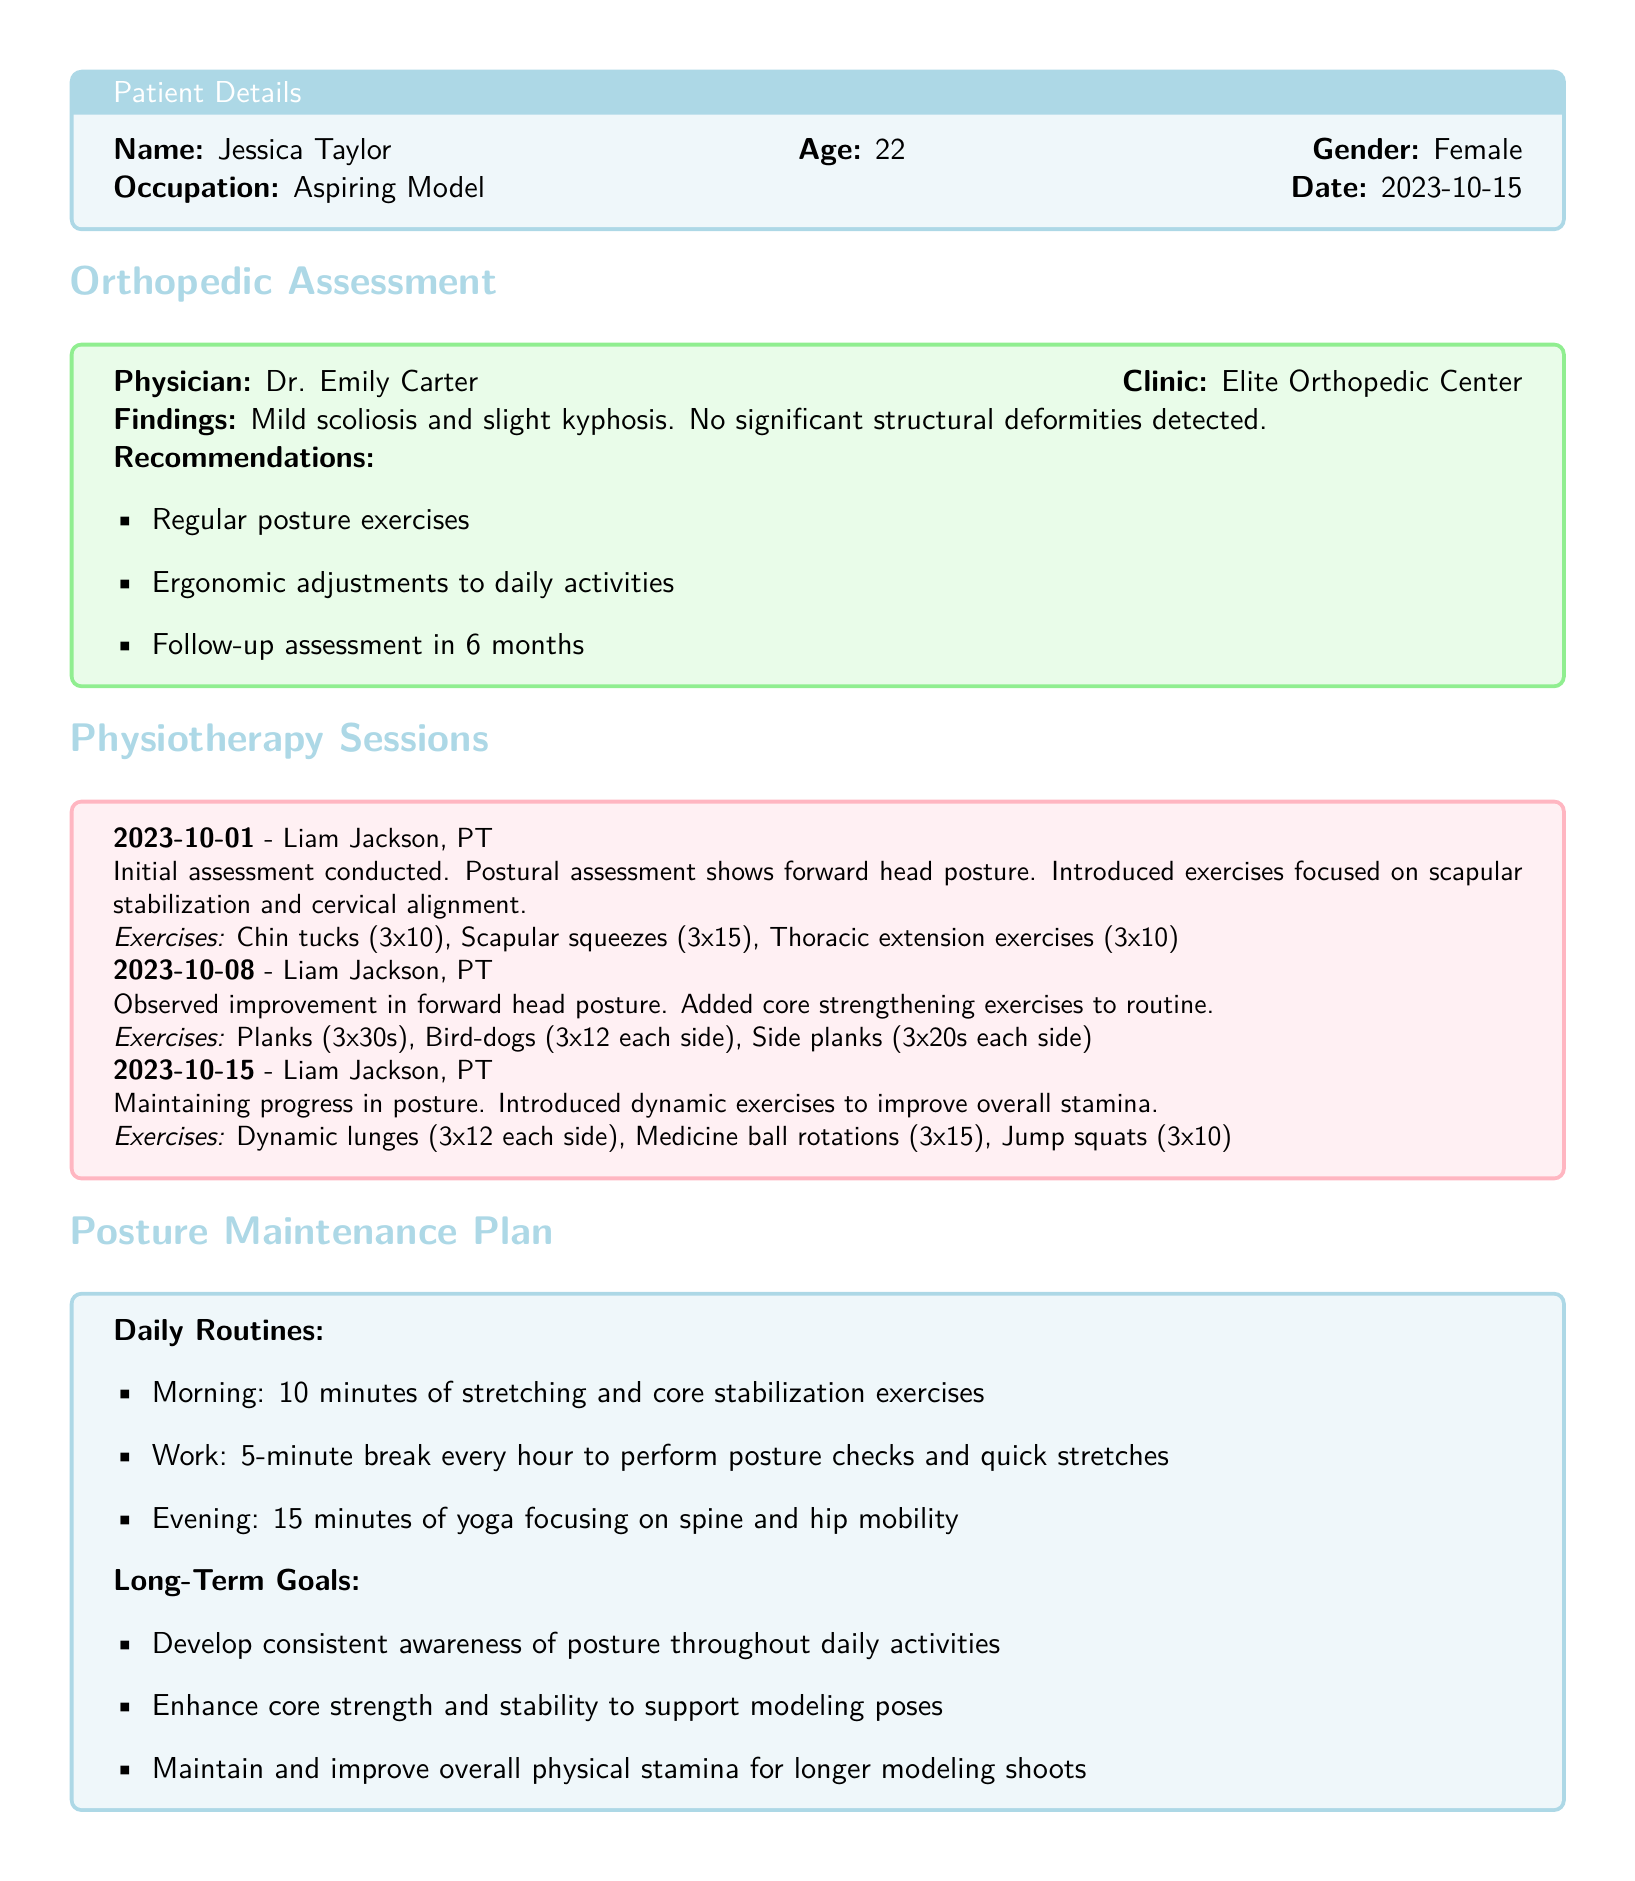What is the name of the patient? The name of the patient is provided in the patient details section.
Answer: Jessica Taylor What is the date of the orthopedic assessment? The date of the orthopedic assessment can be found near the top of the document.
Answer: 2023-10-15 Who conducted the initial physiotherapy assessment? The name of the physiotherapist who conducted the initial assessment is noted in the physiotherapy sessions section.
Answer: Liam Jackson What exercise was introduced on 2023-10-15? The exercise introduced during the session on this date is listed in the physiotherapy sessions section.
Answer: Dynamic lunges What long-term goal is related to core strength? The long-term goal concerning core strength is noted in the posture maintenance plan section.
Answer: Enhance core strength and stability to support modeling poses How many repetitions of thoracic extension exercises are prescribed? The number of repetitions prescribed for thoracic extension exercises is indicated in the details of the physiotherapy sessions.
Answer: 10 What condition was noted in the orthopedic assessment? The condition identified during the orthopedic assessment is specified in the findings.
Answer: Mild scoliosis What is the recommended follow-up period after the assessment? The recommendation for follow-up is mentioned in the orthopedic assessment section.
Answer: 6 months What is the age of the patient? The age of the patient is provided in the patient details section of the document.
Answer: 22 